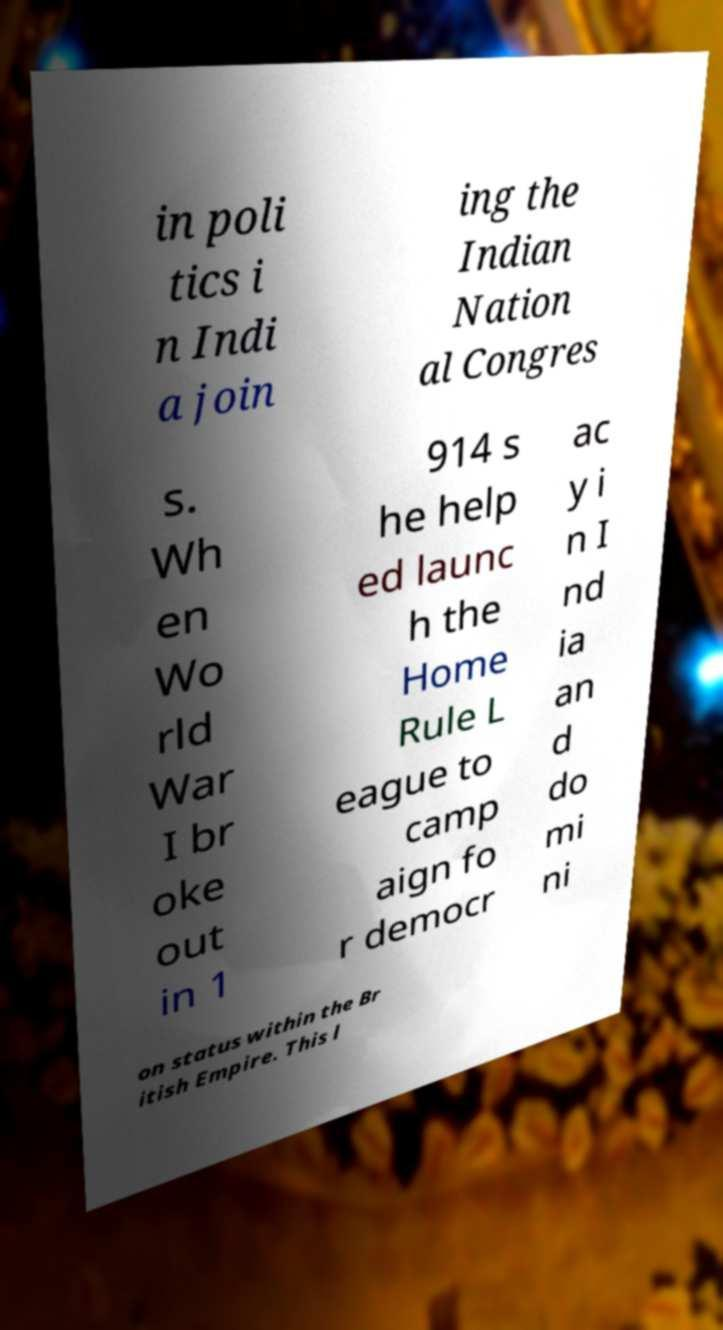Can you read and provide the text displayed in the image?This photo seems to have some interesting text. Can you extract and type it out for me? in poli tics i n Indi a join ing the Indian Nation al Congres s. Wh en Wo rld War I br oke out in 1 914 s he help ed launc h the Home Rule L eague to camp aign fo r democr ac y i n I nd ia an d do mi ni on status within the Br itish Empire. This l 